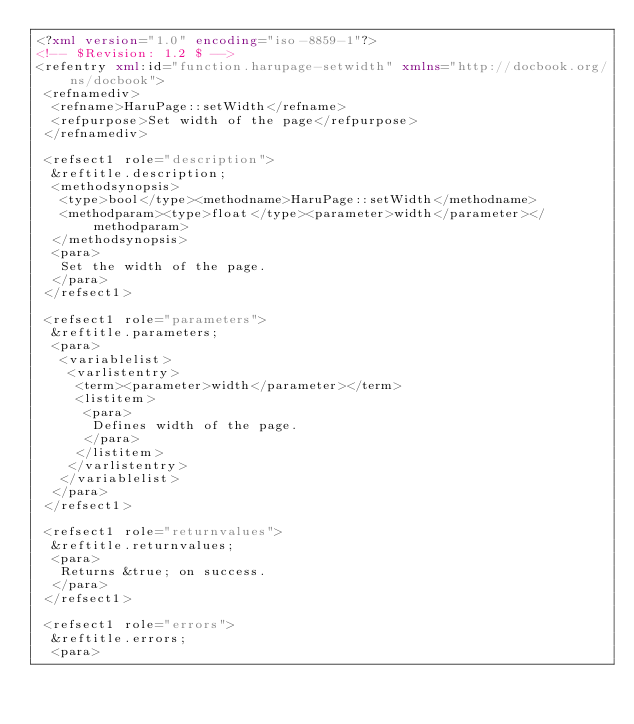Convert code to text. <code><loc_0><loc_0><loc_500><loc_500><_XML_><?xml version="1.0" encoding="iso-8859-1"?>
<!-- $Revision: 1.2 $ -->
<refentry xml:id="function.harupage-setwidth" xmlns="http://docbook.org/ns/docbook">
 <refnamediv>
  <refname>HaruPage::setWidth</refname>
  <refpurpose>Set width of the page</refpurpose>
 </refnamediv>

 <refsect1 role="description">
  &reftitle.description;
  <methodsynopsis>
   <type>bool</type><methodname>HaruPage::setWidth</methodname>
   <methodparam><type>float</type><parameter>width</parameter></methodparam>
  </methodsynopsis>
  <para>
   Set the width of the page.
  </para>
 </refsect1>

 <refsect1 role="parameters">
  &reftitle.parameters;
  <para>
   <variablelist>
    <varlistentry>
     <term><parameter>width</parameter></term>
     <listitem>
      <para>
       Defines width of the page.
      </para>
     </listitem>
    </varlistentry>
   </variablelist>
  </para>
 </refsect1>

 <refsect1 role="returnvalues">
  &reftitle.returnvalues;
  <para>
   Returns &true; on success.
  </para>
 </refsect1>

 <refsect1 role="errors">
  &reftitle.errors;
  <para></code> 